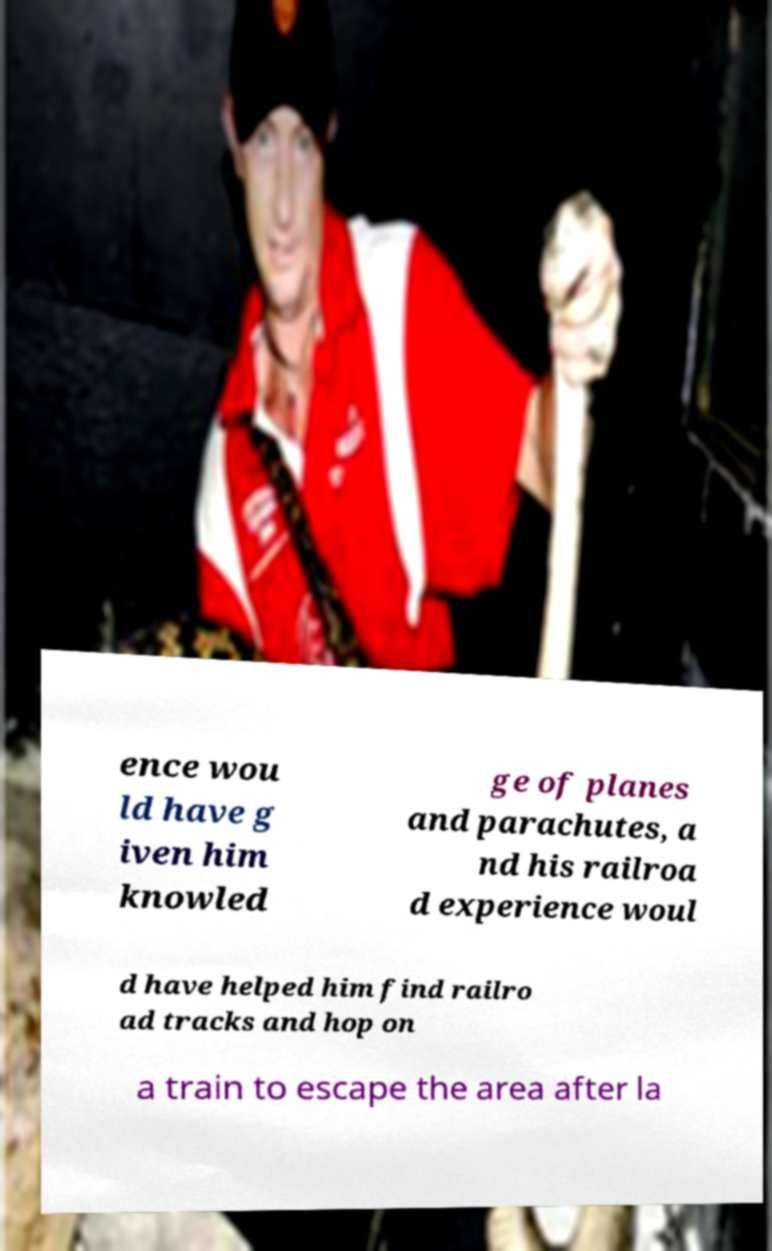There's text embedded in this image that I need extracted. Can you transcribe it verbatim? ence wou ld have g iven him knowled ge of planes and parachutes, a nd his railroa d experience woul d have helped him find railro ad tracks and hop on a train to escape the area after la 